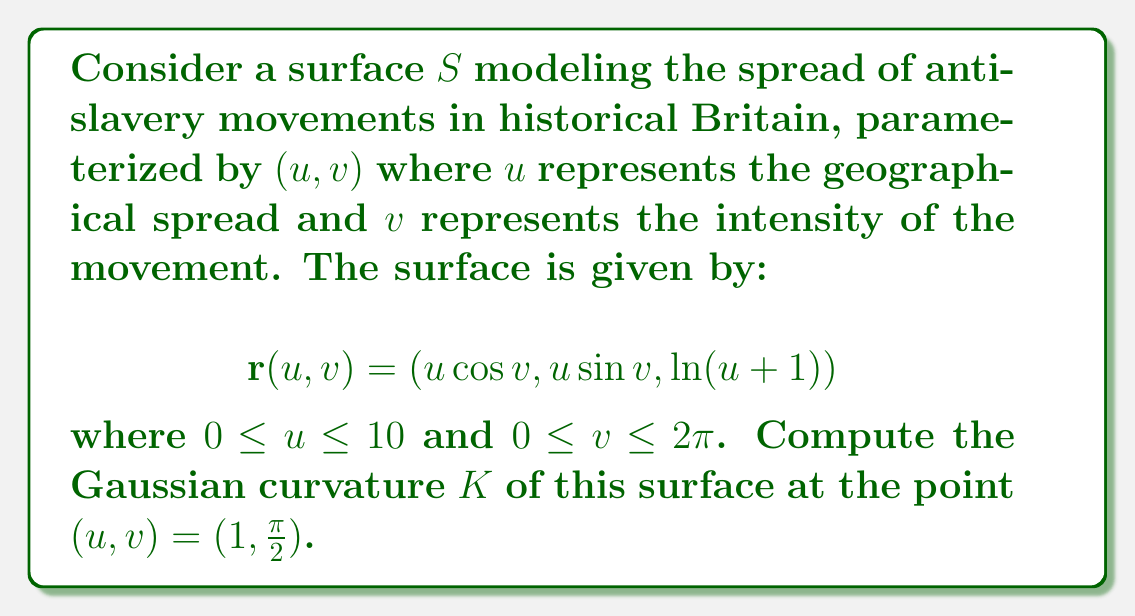Could you help me with this problem? To compute the Gaussian curvature, we'll follow these steps:

1) First, we need to calculate the partial derivatives:
   $$\mathbf{r}_u = (\cos v, \sin v, \frac{1}{u+1})$$
   $$\mathbf{r}_v = (-u\sin v, u\cos v, 0)$$

2) Now, we calculate the second partial derivatives:
   $$\mathbf{r}_{uu} = (0, 0, -\frac{1}{(u+1)^2})$$
   $$\mathbf{r}_{uv} = (-\sin v, \cos v, 0)$$
   $$\mathbf{r}_{vv} = (-u\cos v, -u\sin v, 0)$$

3) Next, we calculate the coefficients of the first fundamental form:
   $$E = \mathbf{r}_u \cdot \mathbf{r}_u = \cos^2 v + \sin^2 v + \frac{1}{(u+1)^2} = 1 + \frac{1}{(u+1)^2}$$
   $$F = \mathbf{r}_u \cdot \mathbf{r}_v = 0$$
   $$G = \mathbf{r}_v \cdot \mathbf{r}_v = u^2$$

4) Now, we calculate the coefficients of the second fundamental form:
   $$\mathbf{n} = \frac{\mathbf{r}_u \times \mathbf{r}_v}{|\mathbf{r}_u \times \mathbf{r}_v|} = \frac{(-\frac{u}{u+1}\sin v, \frac{u}{u+1}\cos v, -u)}{\sqrt{u^2 + \frac{u^2}{(u+1)^2}}}$$
   
   $$e = \mathbf{r}_{uu} \cdot \mathbf{n} = \frac{u}{(u+1)^2\sqrt{u^2 + \frac{u^2}{(u+1)^2}}}$$
   $$f = \mathbf{r}_{uv} \cdot \mathbf{n} = 0$$
   $$g = \mathbf{r}_{vv} \cdot \mathbf{n} = \frac{u^2}{(u+1)\sqrt{u^2 + \frac{u^2}{(u+1)^2}}}$$

5) The Gaussian curvature is given by:
   $$K = \frac{eg-f^2}{EG-F^2}$$

6) Substituting the values at $(u,v) = (1,\frac{\pi}{2})$:
   $$K = \frac{(\frac{1}{4\sqrt{5/4}})(\frac{1}{\sqrt{5/4}}) - 0^2}{(1+\frac{1}{4})(1) - 0^2} = \frac{1/5}{5/4} = \frac{4}{25}$$
Answer: $K = \frac{4}{25}$ 